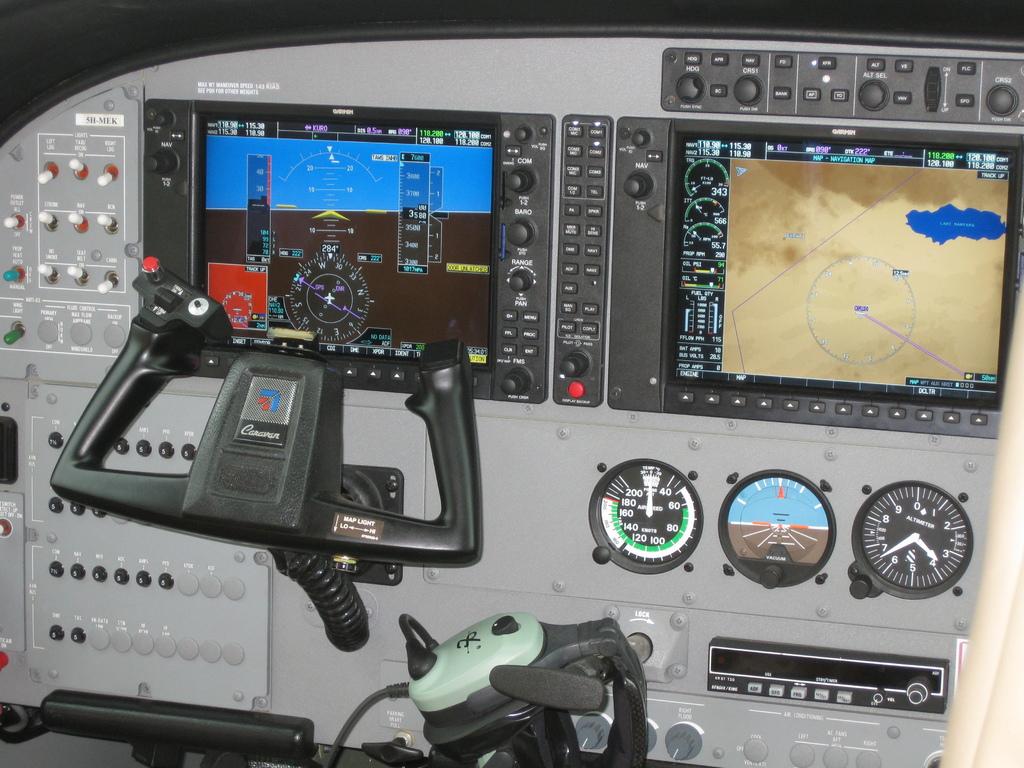What is written on the steering rudder?
Your answer should be very brief. Unanswerable. 